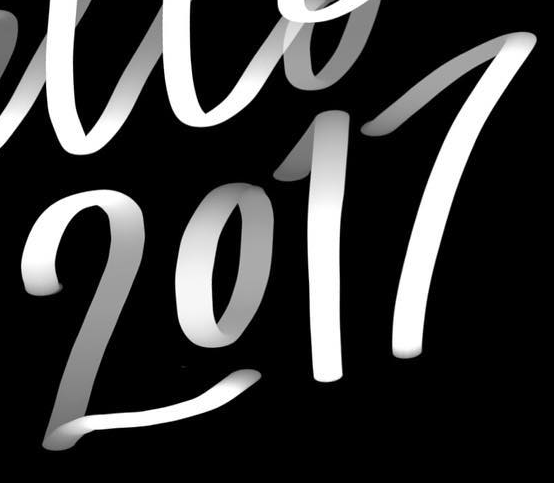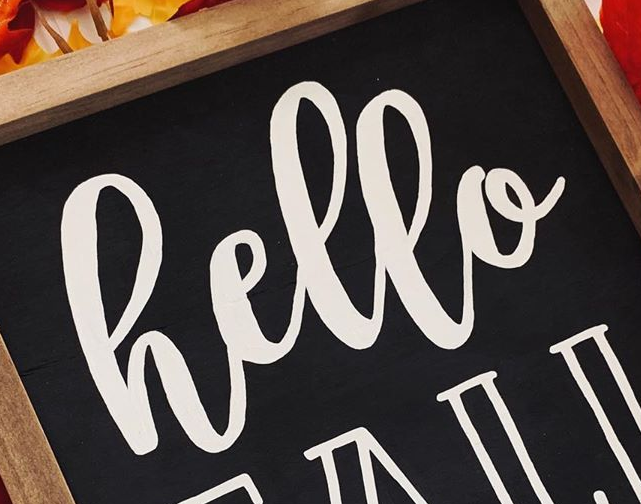What text appears in these images from left to right, separated by a semicolon? 2017; hello 